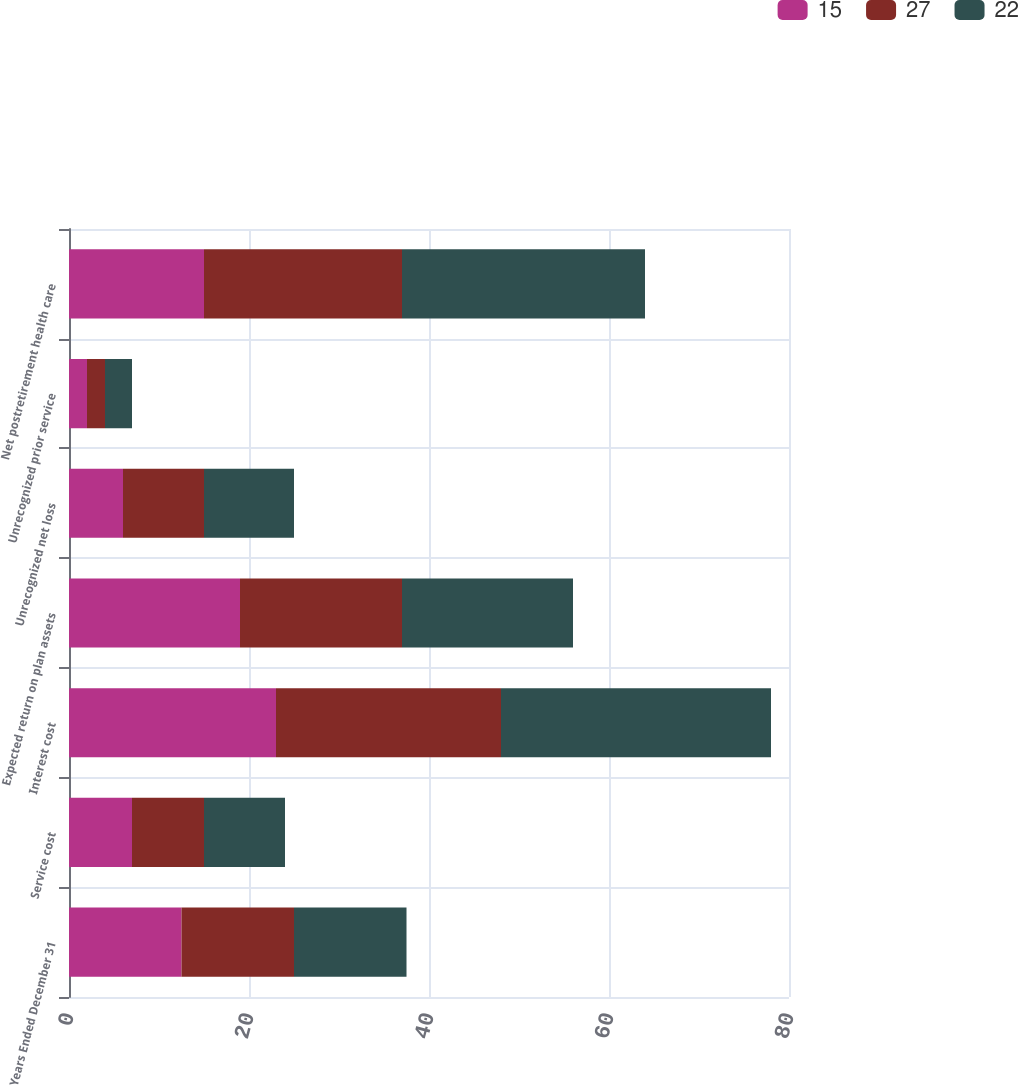Convert chart. <chart><loc_0><loc_0><loc_500><loc_500><stacked_bar_chart><ecel><fcel>Years Ended December 31<fcel>Service cost<fcel>Interest cost<fcel>Expected return on plan assets<fcel>Unrecognized net loss<fcel>Unrecognized prior service<fcel>Net postretirement health care<nl><fcel>15<fcel>12.5<fcel>7<fcel>23<fcel>19<fcel>6<fcel>2<fcel>15<nl><fcel>27<fcel>12.5<fcel>8<fcel>25<fcel>18<fcel>9<fcel>2<fcel>22<nl><fcel>22<fcel>12.5<fcel>9<fcel>30<fcel>19<fcel>10<fcel>3<fcel>27<nl></chart> 